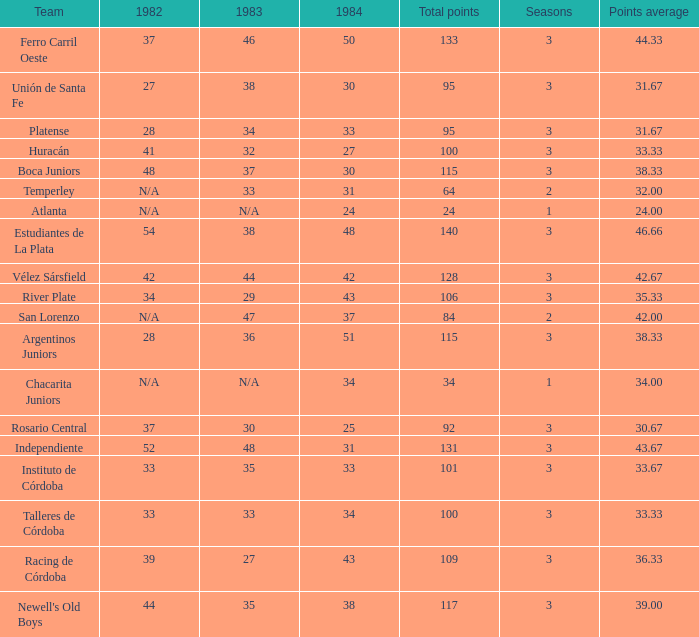Which team experienced 3 seasons and less than 27 in 1984? Rosario Central. Would you be able to parse every entry in this table? {'header': ['Team', '1982', '1983', '1984', 'Total points', 'Seasons', 'Points average'], 'rows': [['Ferro Carril Oeste', '37', '46', '50', '133', '3', '44.33'], ['Unión de Santa Fe', '27', '38', '30', '95', '3', '31.67'], ['Platense', '28', '34', '33', '95', '3', '31.67'], ['Huracán', '41', '32', '27', '100', '3', '33.33'], ['Boca Juniors', '48', '37', '30', '115', '3', '38.33'], ['Temperley', 'N/A', '33', '31', '64', '2', '32.00'], ['Atlanta', 'N/A', 'N/A', '24', '24', '1', '24.00'], ['Estudiantes de La Plata', '54', '38', '48', '140', '3', '46.66'], ['Vélez Sársfield', '42', '44', '42', '128', '3', '42.67'], ['River Plate', '34', '29', '43', '106', '3', '35.33'], ['San Lorenzo', 'N/A', '47', '37', '84', '2', '42.00'], ['Argentinos Juniors', '28', '36', '51', '115', '3', '38.33'], ['Chacarita Juniors', 'N/A', 'N/A', '34', '34', '1', '34.00'], ['Rosario Central', '37', '30', '25', '92', '3', '30.67'], ['Independiente', '52', '48', '31', '131', '3', '43.67'], ['Instituto de Córdoba', '33', '35', '33', '101', '3', '33.67'], ['Talleres de Córdoba', '33', '33', '34', '100', '3', '33.33'], ['Racing de Córdoba', '39', '27', '43', '109', '3', '36.33'], ["Newell's Old Boys", '44', '35', '38', '117', '3', '39.00']]} 